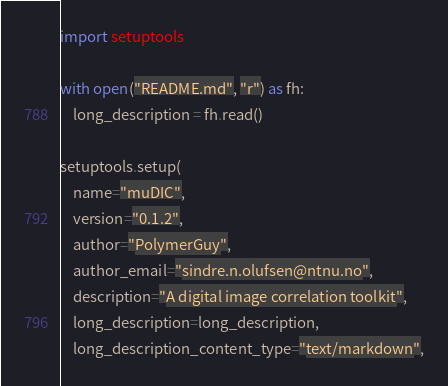Convert code to text. <code><loc_0><loc_0><loc_500><loc_500><_Python_>import setuptools

with open("README.md", "r") as fh:
    long_description = fh.read()

setuptools.setup(
    name="muDIC",
    version="0.1.2",
    author="PolymerGuy",
    author_email="sindre.n.olufsen@ntnu.no",
    description="A digital image correlation toolkit",
    long_description=long_description,
    long_description_content_type="text/markdown",</code> 